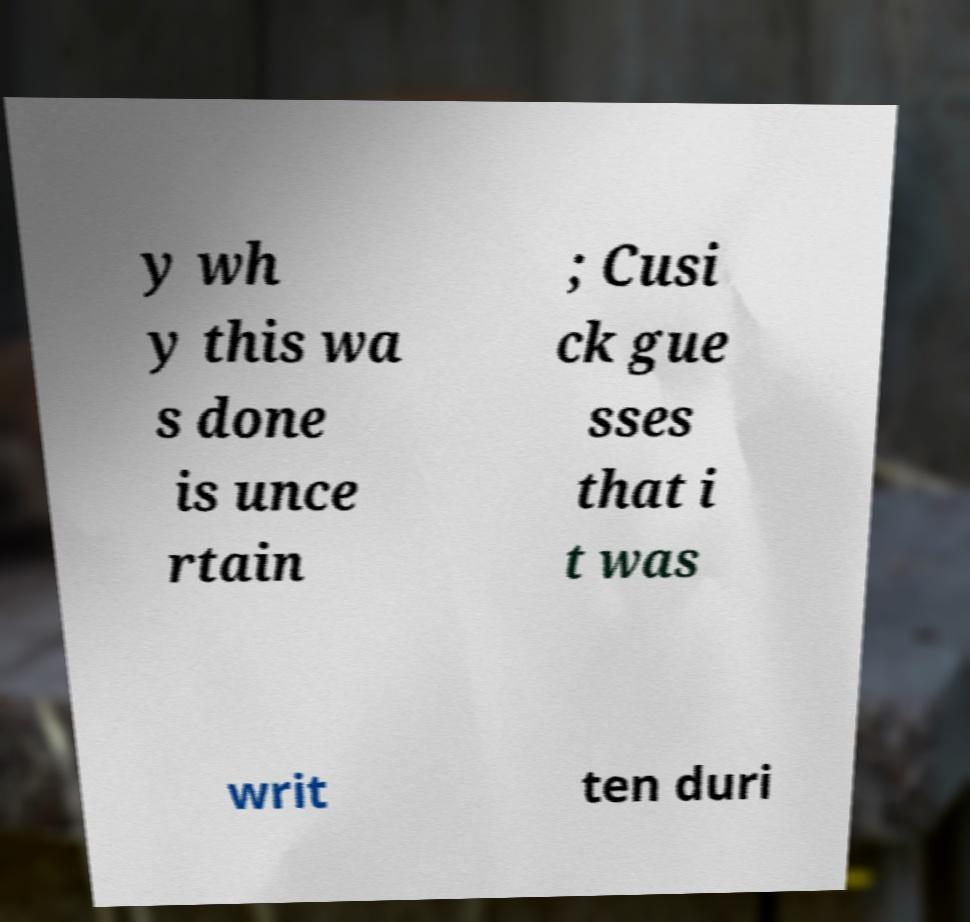What messages or text are displayed in this image? I need them in a readable, typed format. y wh y this wa s done is unce rtain ; Cusi ck gue sses that i t was writ ten duri 